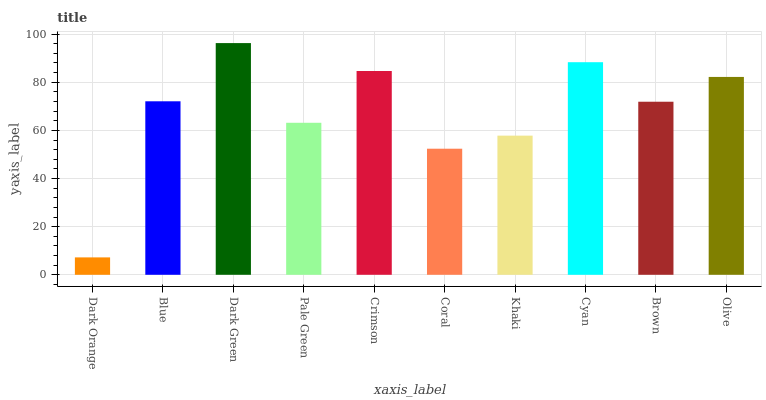Is Dark Orange the minimum?
Answer yes or no. Yes. Is Dark Green the maximum?
Answer yes or no. Yes. Is Blue the minimum?
Answer yes or no. No. Is Blue the maximum?
Answer yes or no. No. Is Blue greater than Dark Orange?
Answer yes or no. Yes. Is Dark Orange less than Blue?
Answer yes or no. Yes. Is Dark Orange greater than Blue?
Answer yes or no. No. Is Blue less than Dark Orange?
Answer yes or no. No. Is Blue the high median?
Answer yes or no. Yes. Is Brown the low median?
Answer yes or no. Yes. Is Crimson the high median?
Answer yes or no. No. Is Blue the low median?
Answer yes or no. No. 